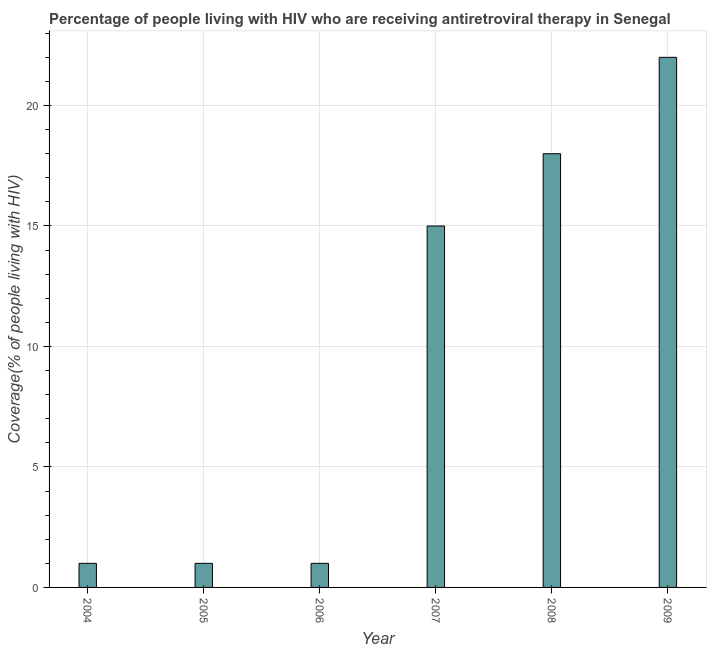What is the title of the graph?
Your answer should be compact. Percentage of people living with HIV who are receiving antiretroviral therapy in Senegal. What is the label or title of the Y-axis?
Provide a short and direct response. Coverage(% of people living with HIV). Across all years, what is the maximum antiretroviral therapy coverage?
Offer a terse response. 22. In which year was the antiretroviral therapy coverage maximum?
Ensure brevity in your answer.  2009. In which year was the antiretroviral therapy coverage minimum?
Give a very brief answer. 2004. What is the sum of the antiretroviral therapy coverage?
Your answer should be compact. 58. What is the difference between the antiretroviral therapy coverage in 2004 and 2005?
Keep it short and to the point. 0. In how many years, is the antiretroviral therapy coverage greater than 8 %?
Offer a very short reply. 3. Do a majority of the years between 2008 and 2009 (inclusive) have antiretroviral therapy coverage greater than 22 %?
Provide a short and direct response. No. What is the ratio of the antiretroviral therapy coverage in 2004 to that in 2007?
Give a very brief answer. 0.07. What is the difference between the highest and the second highest antiretroviral therapy coverage?
Offer a very short reply. 4. How many years are there in the graph?
Your answer should be very brief. 6. Are the values on the major ticks of Y-axis written in scientific E-notation?
Your answer should be compact. No. What is the Coverage(% of people living with HIV) of 2004?
Ensure brevity in your answer.  1. What is the Coverage(% of people living with HIV) in 2009?
Ensure brevity in your answer.  22. What is the difference between the Coverage(% of people living with HIV) in 2004 and 2005?
Offer a very short reply. 0. What is the difference between the Coverage(% of people living with HIV) in 2004 and 2006?
Keep it short and to the point. 0. What is the difference between the Coverage(% of people living with HIV) in 2004 and 2007?
Make the answer very short. -14. What is the difference between the Coverage(% of people living with HIV) in 2004 and 2009?
Ensure brevity in your answer.  -21. What is the difference between the Coverage(% of people living with HIV) in 2005 and 2007?
Provide a succinct answer. -14. What is the difference between the Coverage(% of people living with HIV) in 2005 and 2009?
Provide a succinct answer. -21. What is the difference between the Coverage(% of people living with HIV) in 2007 and 2008?
Make the answer very short. -3. What is the ratio of the Coverage(% of people living with HIV) in 2004 to that in 2006?
Make the answer very short. 1. What is the ratio of the Coverage(% of people living with HIV) in 2004 to that in 2007?
Offer a terse response. 0.07. What is the ratio of the Coverage(% of people living with HIV) in 2004 to that in 2008?
Keep it short and to the point. 0.06. What is the ratio of the Coverage(% of people living with HIV) in 2004 to that in 2009?
Your answer should be very brief. 0.04. What is the ratio of the Coverage(% of people living with HIV) in 2005 to that in 2007?
Provide a short and direct response. 0.07. What is the ratio of the Coverage(% of people living with HIV) in 2005 to that in 2008?
Keep it short and to the point. 0.06. What is the ratio of the Coverage(% of people living with HIV) in 2005 to that in 2009?
Ensure brevity in your answer.  0.04. What is the ratio of the Coverage(% of people living with HIV) in 2006 to that in 2007?
Give a very brief answer. 0.07. What is the ratio of the Coverage(% of people living with HIV) in 2006 to that in 2008?
Provide a short and direct response. 0.06. What is the ratio of the Coverage(% of people living with HIV) in 2006 to that in 2009?
Your answer should be very brief. 0.04. What is the ratio of the Coverage(% of people living with HIV) in 2007 to that in 2008?
Offer a terse response. 0.83. What is the ratio of the Coverage(% of people living with HIV) in 2007 to that in 2009?
Your answer should be very brief. 0.68. What is the ratio of the Coverage(% of people living with HIV) in 2008 to that in 2009?
Offer a terse response. 0.82. 